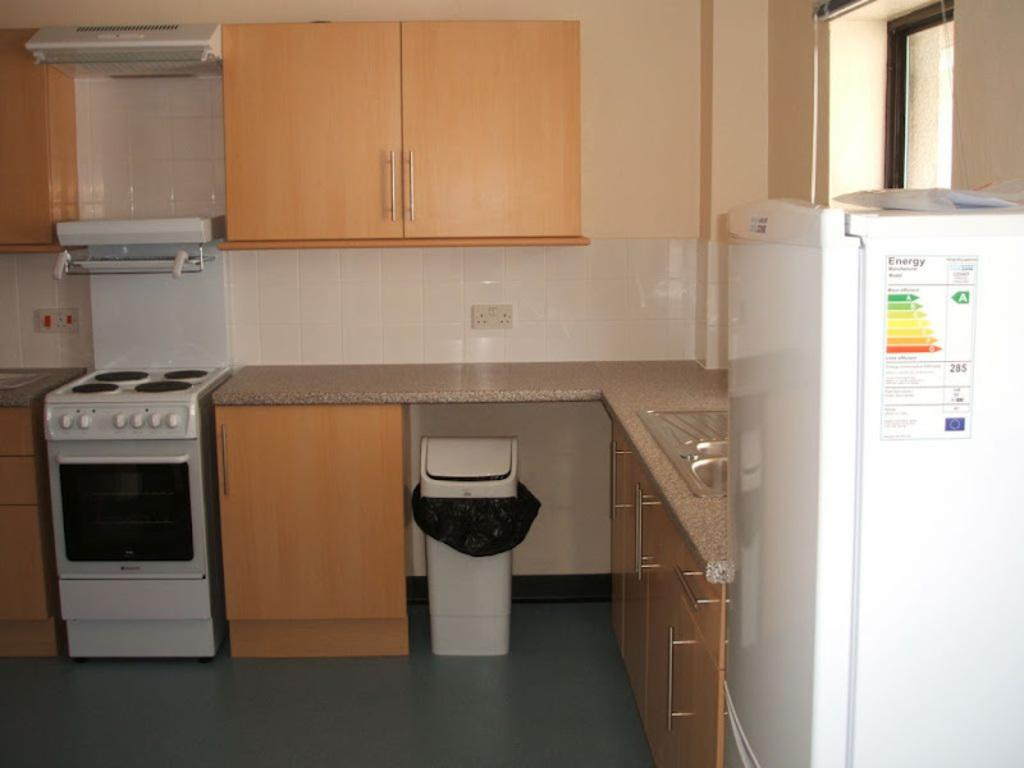Provide a one-sentence caption for the provided image. A clean kitchen with the Energy sticker still in place on the fridge. 